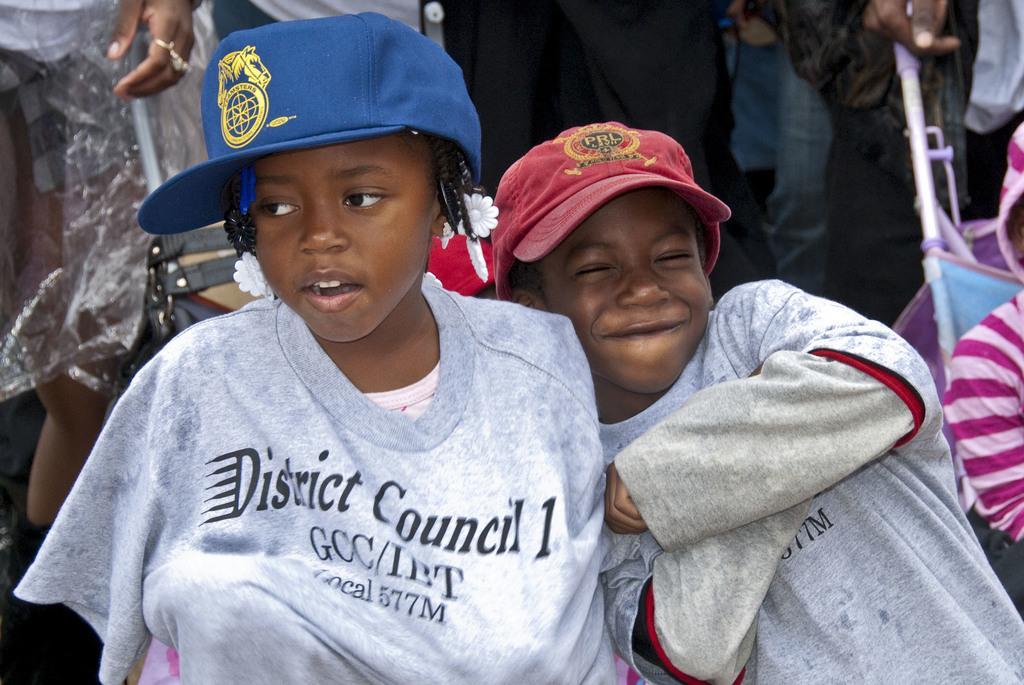Please provide a concise description of this image. In this image, in the middle, we can see a two kids wearing red color and blue color hat. In the background, we can see a group of people. On the right side, we can see a kid sitting in the bouncer. 